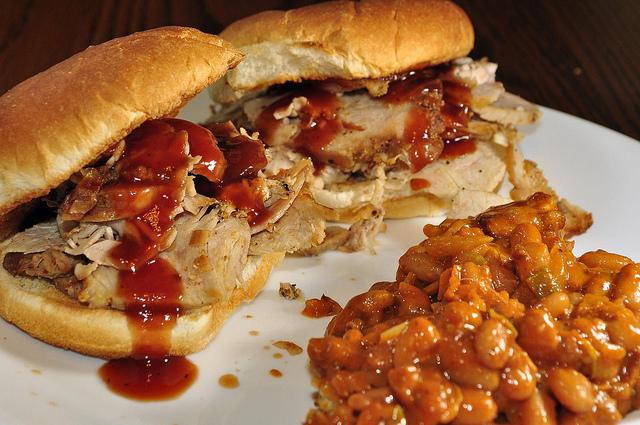There are two sandwiches?
Quick response, please. Yes. Which food is this?
Keep it brief. Barbecue. What kind of sauce is on the sandwiches?
Give a very brief answer. Bbq. What is the melted orange stuff called?
Give a very brief answer. Cheese. What side came with the sandwich?
Answer briefly. Beans. How many sandwiches are on the plate?
Write a very short answer. 2. 